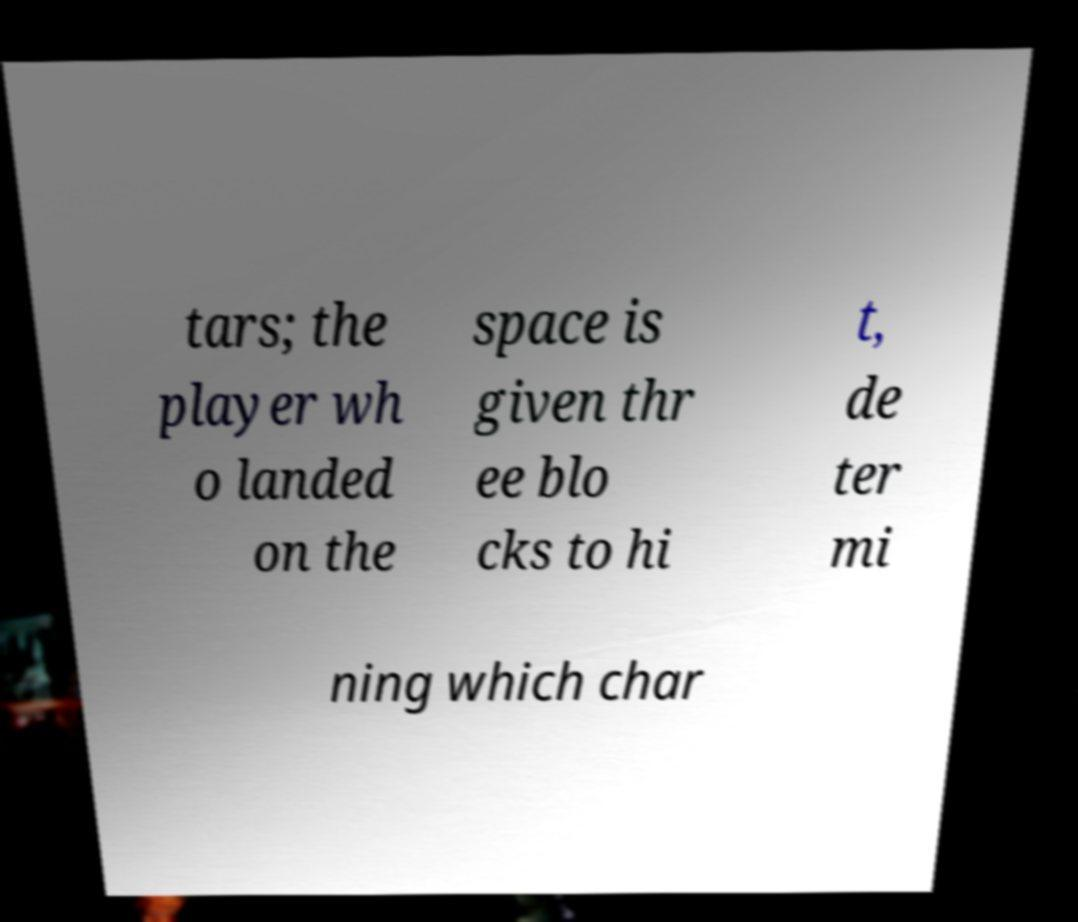Can you accurately transcribe the text from the provided image for me? tars; the player wh o landed on the space is given thr ee blo cks to hi t, de ter mi ning which char 